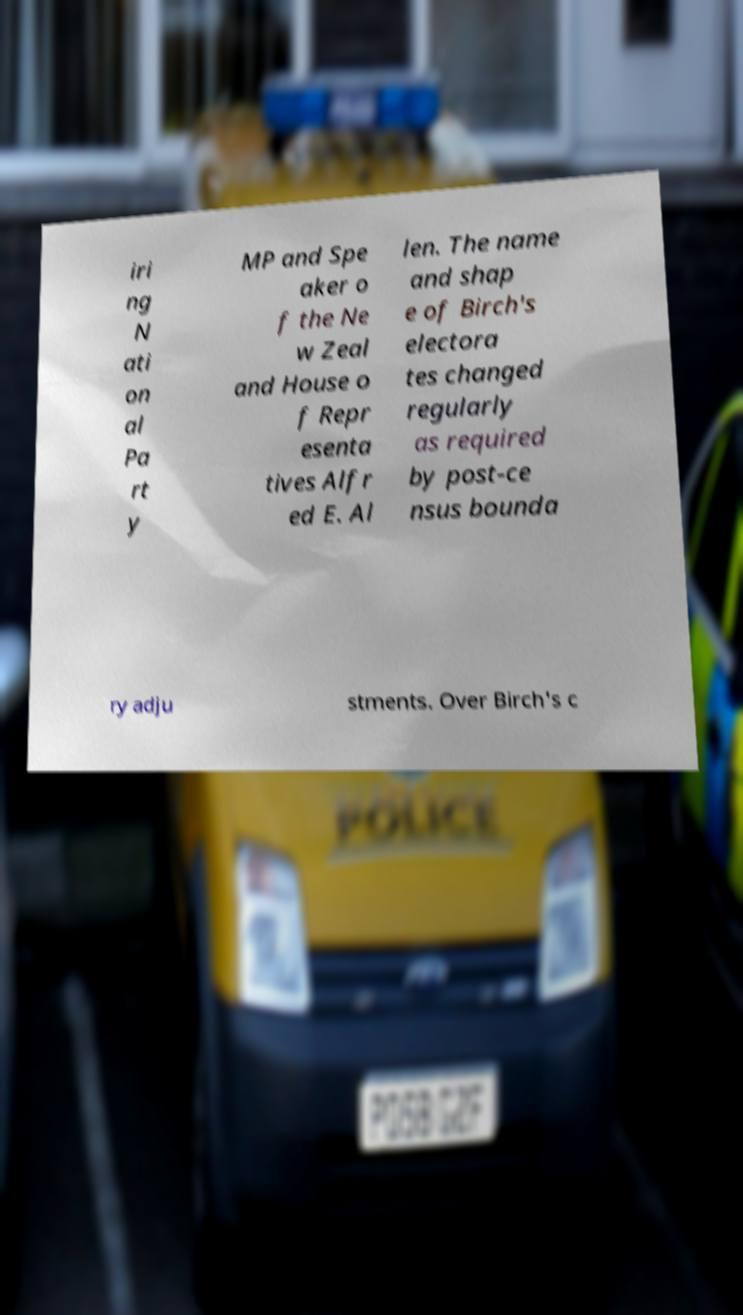What messages or text are displayed in this image? I need them in a readable, typed format. iri ng N ati on al Pa rt y MP and Spe aker o f the Ne w Zeal and House o f Repr esenta tives Alfr ed E. Al len. The name and shap e of Birch's electora tes changed regularly as required by post-ce nsus bounda ry adju stments. Over Birch's c 